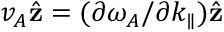<formula> <loc_0><loc_0><loc_500><loc_500>v _ { A } \hat { z } = ( \partial \omega _ { A } / \partial k _ { \| } ) \hat { z }</formula> 